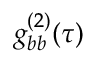<formula> <loc_0><loc_0><loc_500><loc_500>g _ { b b } ^ { ( 2 ) } ( \tau )</formula> 